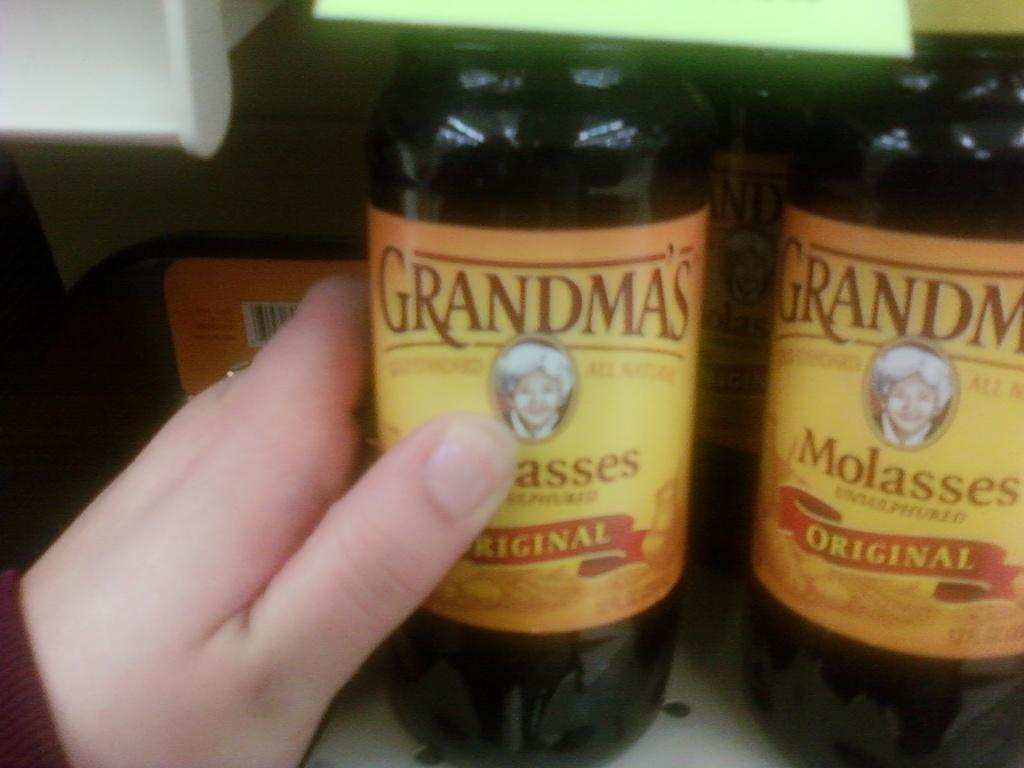<image>
Share a concise interpretation of the image provided. Bottles of Grandmas Molasses are sitting on a shelf. 